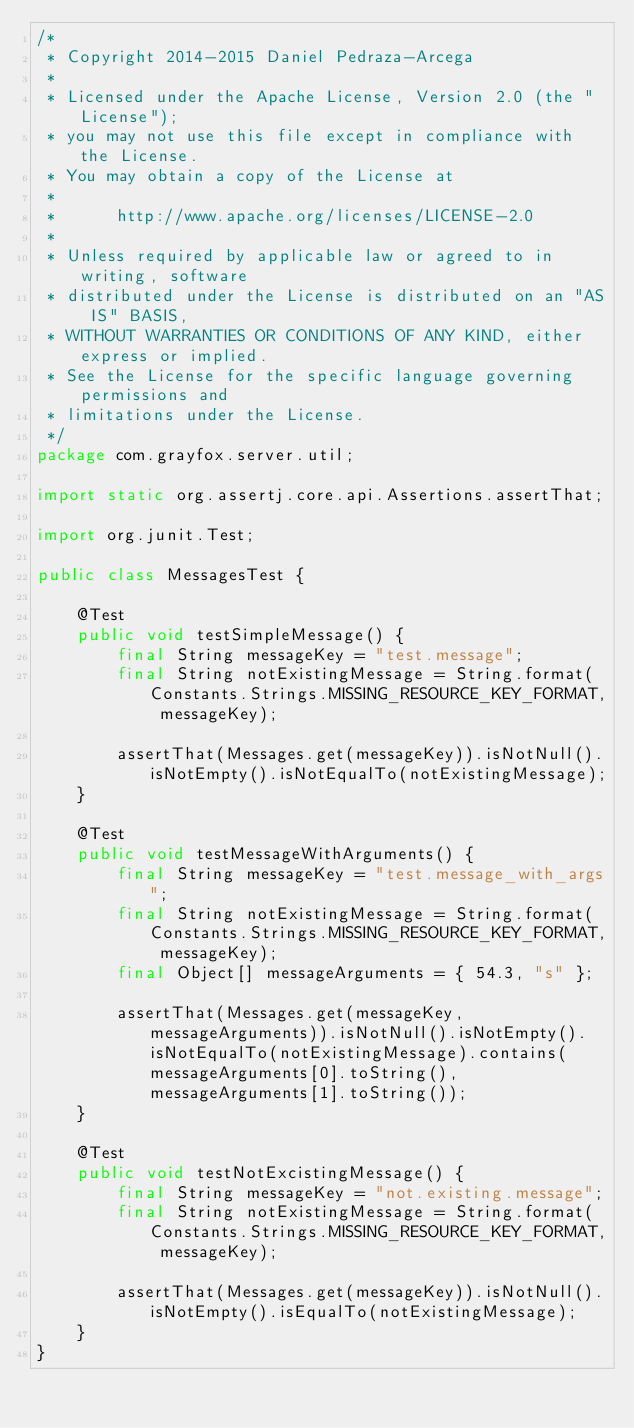Convert code to text. <code><loc_0><loc_0><loc_500><loc_500><_Java_>/*
 * Copyright 2014-2015 Daniel Pedraza-Arcega
 *
 * Licensed under the Apache License, Version 2.0 (the "License");
 * you may not use this file except in compliance with the License.
 * You may obtain a copy of the License at
 *
 *      http://www.apache.org/licenses/LICENSE-2.0
 *
 * Unless required by applicable law or agreed to in writing, software
 * distributed under the License is distributed on an "AS IS" BASIS,
 * WITHOUT WARRANTIES OR CONDITIONS OF ANY KIND, either express or implied.
 * See the License for the specific language governing permissions and
 * limitations under the License.
 */
package com.grayfox.server.util;

import static org.assertj.core.api.Assertions.assertThat;

import org.junit.Test;

public class MessagesTest {

    @Test
    public void testSimpleMessage() {
        final String messageKey = "test.message";
        final String notExistingMessage = String.format(Constants.Strings.MISSING_RESOURCE_KEY_FORMAT, messageKey);

        assertThat(Messages.get(messageKey)).isNotNull().isNotEmpty().isNotEqualTo(notExistingMessage);
    }

    @Test
    public void testMessageWithArguments() {
        final String messageKey = "test.message_with_args";
        final String notExistingMessage = String.format(Constants.Strings.MISSING_RESOURCE_KEY_FORMAT, messageKey);
        final Object[] messageArguments = { 54.3, "s" };

        assertThat(Messages.get(messageKey, messageArguments)).isNotNull().isNotEmpty().isNotEqualTo(notExistingMessage).contains(messageArguments[0].toString(), messageArguments[1].toString());
    }

    @Test
    public void testNotExcistingMessage() {
        final String messageKey = "not.existing.message";
        final String notExistingMessage = String.format(Constants.Strings.MISSING_RESOURCE_KEY_FORMAT, messageKey);

        assertThat(Messages.get(messageKey)).isNotNull().isNotEmpty().isEqualTo(notExistingMessage);
    }
}</code> 